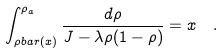Convert formula to latex. <formula><loc_0><loc_0><loc_500><loc_500>\int _ { \rho b a r ( x ) } ^ { \rho _ { a } } \frac { d \rho } { J - \lambda \rho ( 1 - \rho ) } & = x \quad .</formula> 